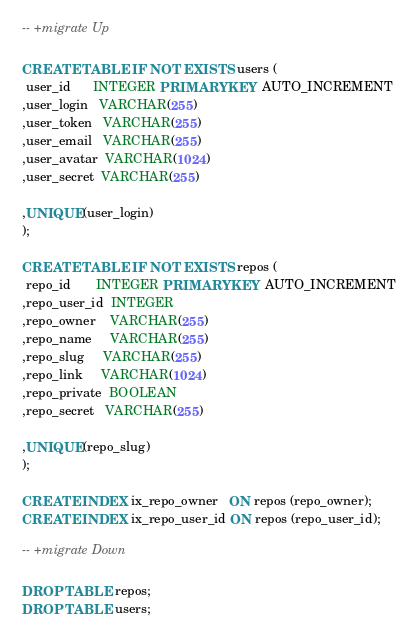Convert code to text. <code><loc_0><loc_0><loc_500><loc_500><_SQL_>-- +migrate Up

CREATE TABLE IF NOT EXISTS users (
 user_id      INTEGER PRIMARY KEY AUTO_INCREMENT
,user_login   VARCHAR(255)
,user_token   VARCHAR(255)
,user_email   VARCHAR(255)
,user_avatar  VARCHAR(1024)
,user_secret  VARCHAR(255)

,UNIQUE(user_login)
);

CREATE TABLE IF NOT EXISTS repos (
 repo_id       INTEGER PRIMARY KEY AUTO_INCREMENT
,repo_user_id  INTEGER
,repo_owner    VARCHAR(255)
,repo_name     VARCHAR(255)
,repo_slug     VARCHAR(255)
,repo_link     VARCHAR(1024)
,repo_private  BOOLEAN
,repo_secret   VARCHAR(255)

,UNIQUE(repo_slug)
);

CREATE INDEX ix_repo_owner   ON repos (repo_owner);
CREATE INDEX ix_repo_user_id ON repos (repo_user_id);

-- +migrate Down

DROP TABLE repos;
DROP TABLE users;
</code> 